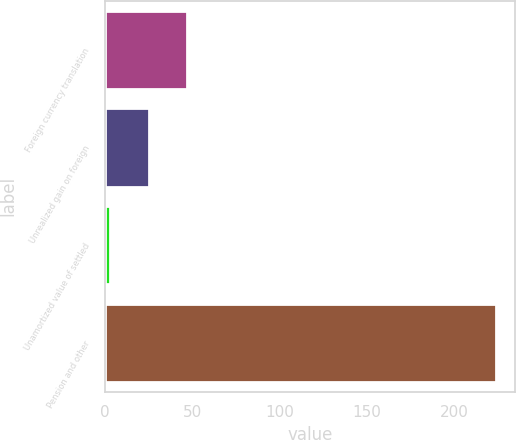<chart> <loc_0><loc_0><loc_500><loc_500><bar_chart><fcel>Foreign currency translation<fcel>Unrealized gain on foreign<fcel>Unamortized value of settled<fcel>Pension and other<nl><fcel>47.12<fcel>25.01<fcel>2.9<fcel>224<nl></chart> 